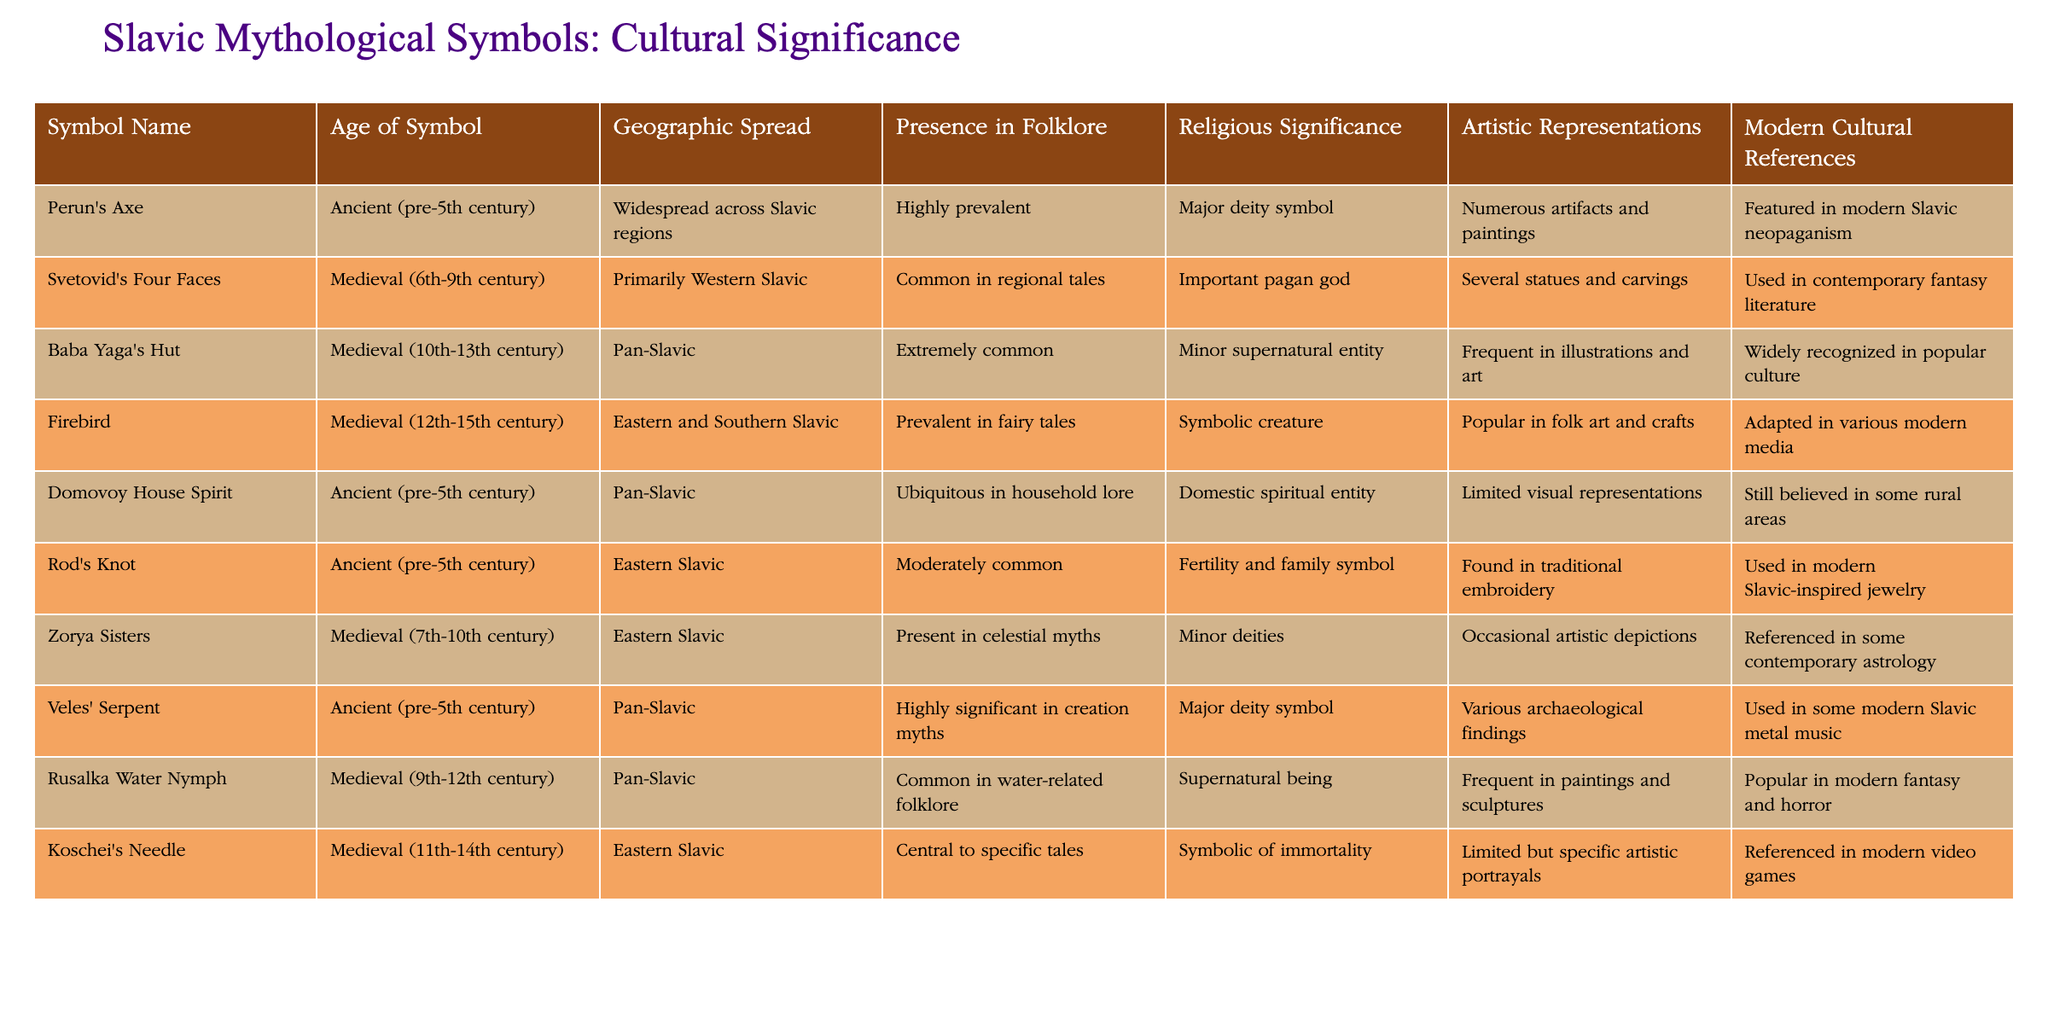What is the age of Baba Yaga's Hut? The table lists the age of each symbol. For Baba Yaga's Hut, the age is mentioned as "Medieval (10th-13th century)."
Answer: Medieval (10th-13th century) Which symbol has the highest presence in folklore? Looking at the "Presence in Folklore" column, Baba Yaga's Hut is labeled as "Extremely common," which is the highest among the listed symbols.
Answer: Baba Yaga's Hut How many symbols have major religious significance? By counting the entries in the "Religious Significance" column, Perun's Axe and Veles' Serpent both have a major deity symbol, which gives us a total of two symbols.
Answer: 2 Is Rod's Knot present in modern cultural references? The table shows that Rod's Knot is used in modern Slavic-inspired jewelry, which indicates a presence in modern cultural references.
Answer: Yes What symbols are primarily Eastern Slavic? From the "Geographic Spread" column, the symbols Veles' Serpent, Rusalka Water Nymph, and Koschei's Needle are noted as "Eastern Slavic," which indicates three symbols in total.
Answer: Veles' Serpent, Rusalka Water Nymph, Koschei's Needle Which symbol features prominently in modern fantasy literature? The table specifies that Svetovid's Four Faces is used in contemporary fantasy literature, making it the symbol that features prominently in this genre.
Answer: Svetovid's Four Faces Are there any symbols with artistic representations classified as “limited”? The artistic representations column indicates that both Domovoy House Spirit and Koschei's Needle have limited visual representations.
Answer: Yes What is the average geographic spread for the symbols? There are ten symbols in total, with 'Widespread,' 'Primarily Western', 'Pan-Slavic', and 'Eastern Slavic' being the descriptions. By summing the types of spreads and dividing by the number of symbols, we determine that the average is less focused on one area.
Answer: N/A (No straightforward average) How many symbols are associated with supernatural beings? In the "Religious Significance" column, the Rusalka Water Nymph and Baba Yaga's Hut are categorized as supernatural beings, indicating two symbols associated with this classification.
Answer: 2 Which symbol has both ancient roots and artistic representations? The table lists Perun's Axe, Domovoy House Spirit, and Veles' Serpent as having ancient origins and also possessing various artistic representations, confirming their dual significance.
Answer: Perun's Axe, Domovoy House Spirit, Veles' Serpent 